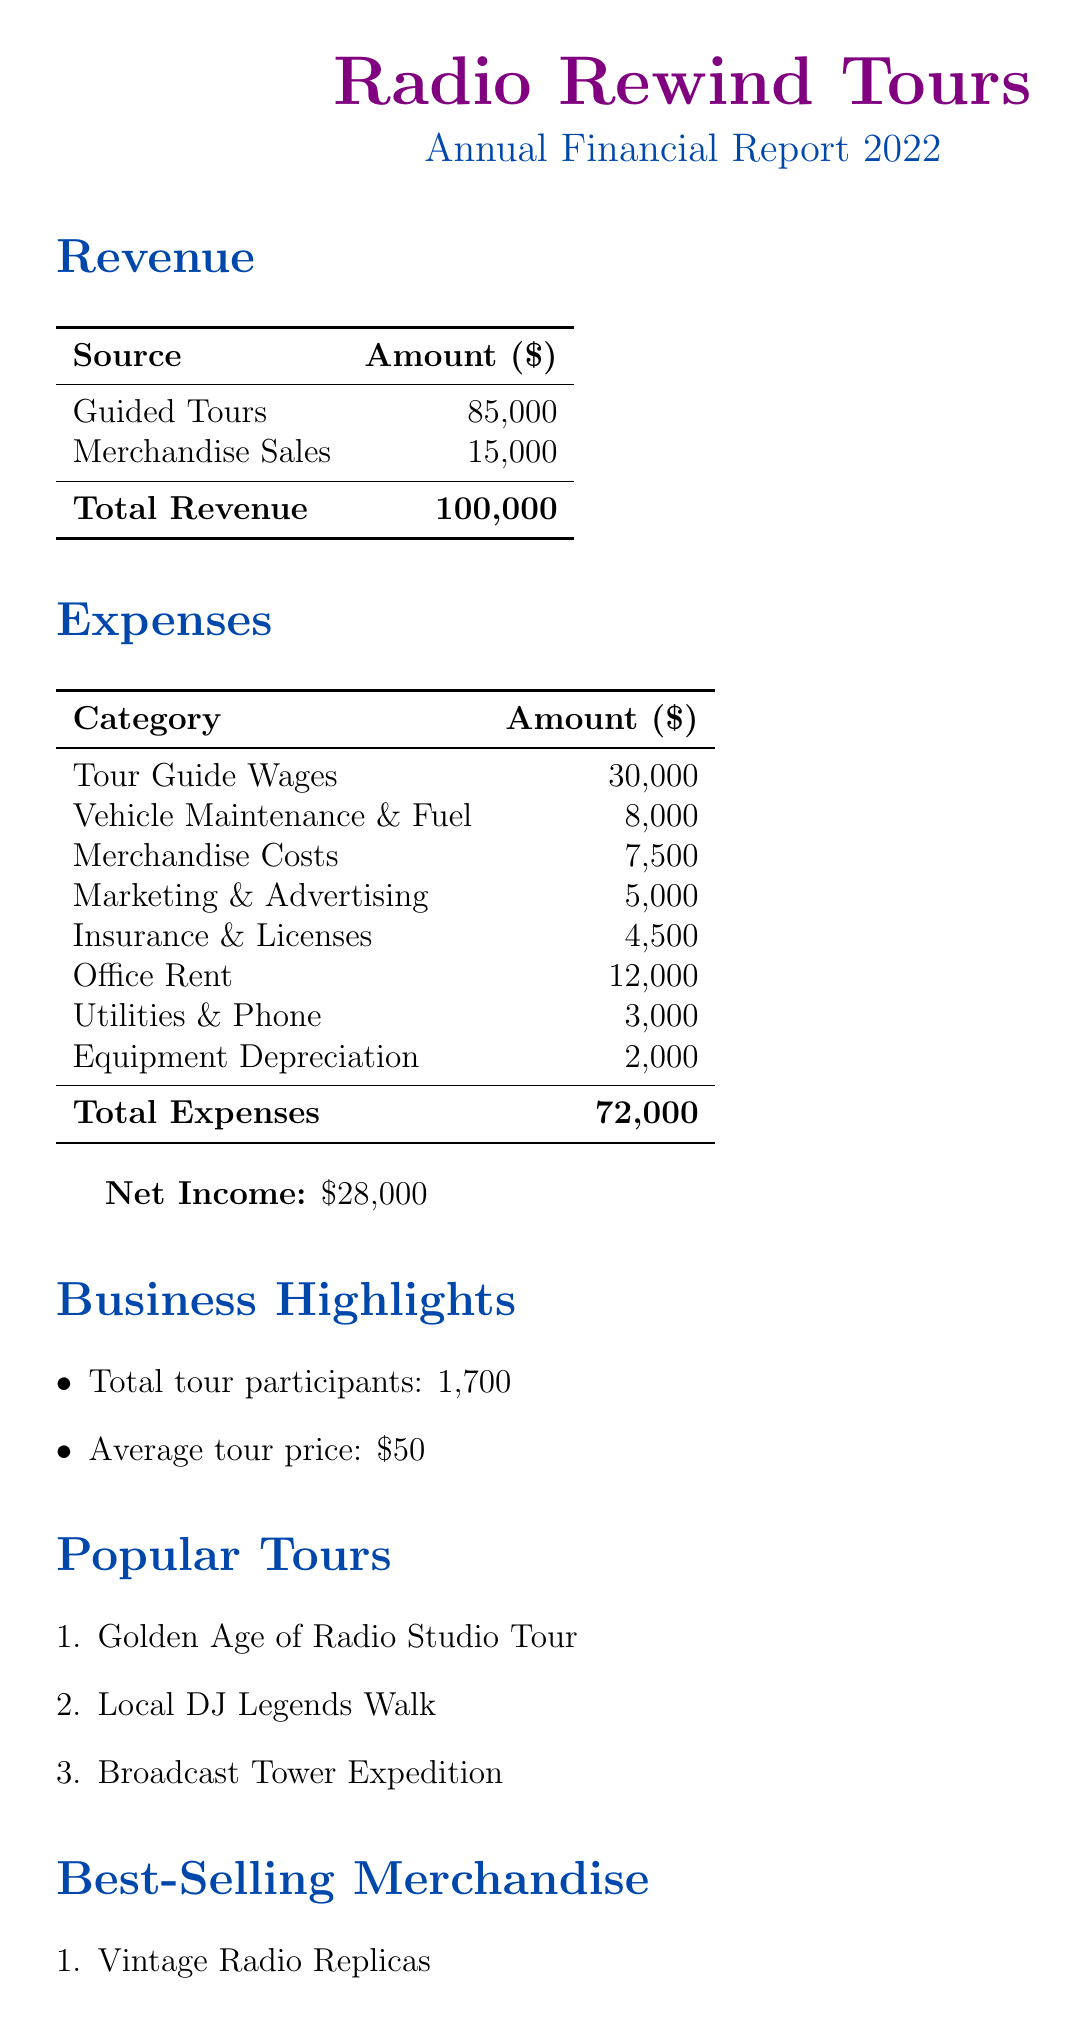What was the total revenue for Radio Rewind Tours in 2022? The total revenue is shown in the revenue section of the document as $100,000.
Answer: $100,000 How much did Radio Rewind Tours earn from guided tours? The revenue from guided tours is provided specifically in the revenue section as $85,000.
Answer: $85,000 What are the total expenses listed in the document? The total expenses are summarized in the expenses section as $72,000.
Answer: $72,000 What is the net income for the year 2022? The net income is highlighted in the document as $28,000.
Answer: $28,000 How many tour participants did Radio Rewind Tours have in 2022? The total number of tour participants is mentioned in the business highlights as 1,700.
Answer: 1,700 What was the average price of a tour? The average tour price is noted in the business highlights as $50.
Answer: $50 Which tour is listed first as a popular tour? The first popular tour mentioned in the document is the "Golden Age of Radio Studio Tour."
Answer: Golden Age of Radio Studio Tour What were the best-selling merchandise items? The document lists the best-selling items, with the first being "Vintage Radio Replicas."
Answer: Vintage Radio Replicas What expense category had the highest amount? The document specifies that tour guide wages are the highest expense at $30,000.
Answer: Tour Guide Wages 